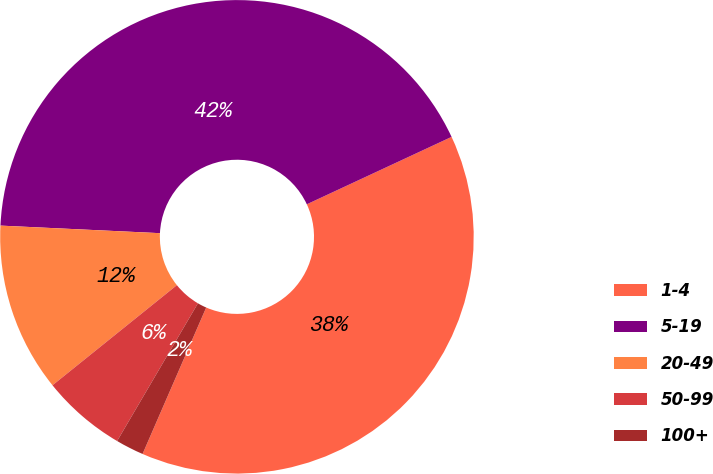Convert chart to OTSL. <chart><loc_0><loc_0><loc_500><loc_500><pie_chart><fcel>1-4<fcel>5-19<fcel>20-49<fcel>50-99<fcel>100+<nl><fcel>38.46%<fcel>42.31%<fcel>11.54%<fcel>5.77%<fcel>1.92%<nl></chart> 